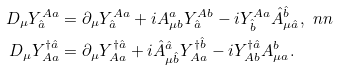Convert formula to latex. <formula><loc_0><loc_0><loc_500><loc_500>D _ { \mu } Y ^ { A a } _ { \hat { a } } & = \partial _ { \mu } Y ^ { A a } _ { \hat { a } } + i A ^ { a } _ { \mu b } Y ^ { A b } _ { \hat { a } } - i Y ^ { A a } _ { \hat { b } } \hat { A } ^ { \hat { b } } _ { \mu \hat { a } } , \ n n \\ D _ { \mu } Y ^ { \dagger \hat { a } } _ { A a } & = \partial _ { \mu } Y ^ { \dagger \hat { a } } _ { A a } + i \hat { A } ^ { \hat { a } } _ { \mu \hat { b } } Y ^ { \dagger \hat { b } } _ { A a } - i Y ^ { \dagger \hat { a } } _ { A b } A ^ { b } _ { \mu a } .</formula> 